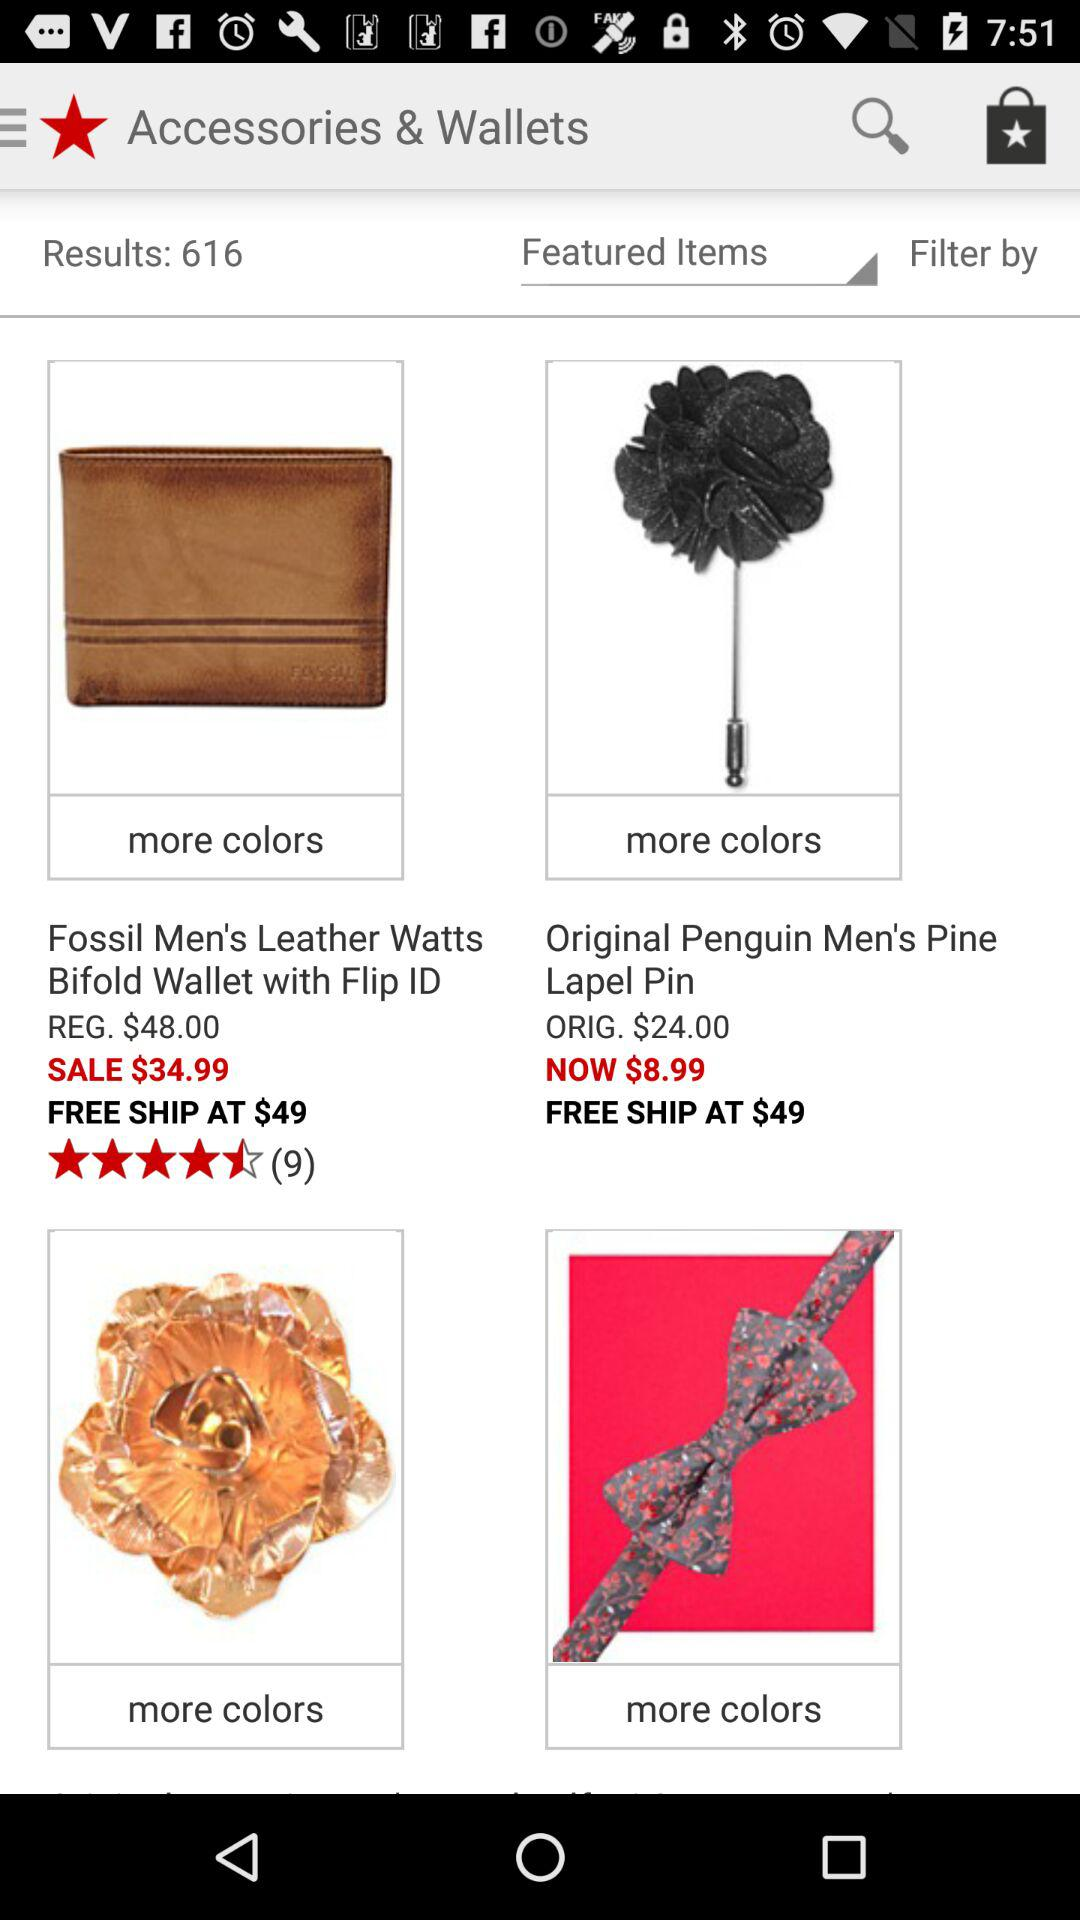What is the regular price of the "Bifold Wallet"? The regular price is $48. 